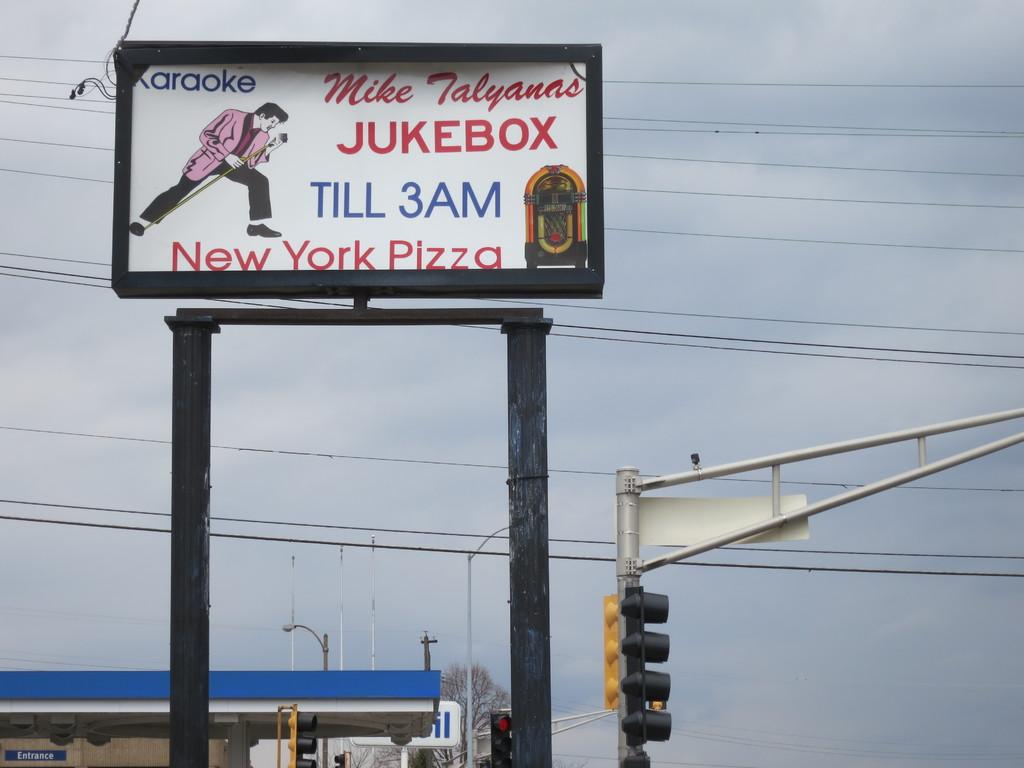<image>
Relay a brief, clear account of the picture shown. An advertisement for Mike Talyanns Karaoke Jukebox says they are open until 3 AM and serve New York Pizza. 